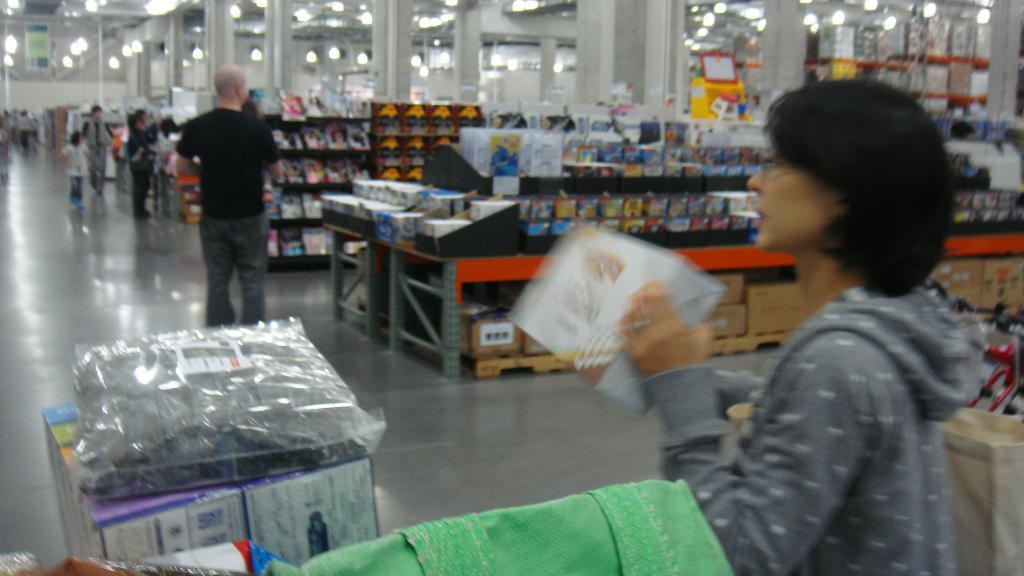In one or two sentences, can you explain what this image depicts? In this image we can see few persons. In the foreground we can see a person holding an object. Behind the person in the foreground we can see a group of objects on the tables and racks. At the top we can see roof, poles and lights. At the bottom we can see few objects. 